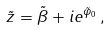Convert formula to latex. <formula><loc_0><loc_0><loc_500><loc_500>\tilde { z } = \tilde { \beta } + i e ^ { \tilde { \varphi } _ { 0 } } \, ,</formula> 